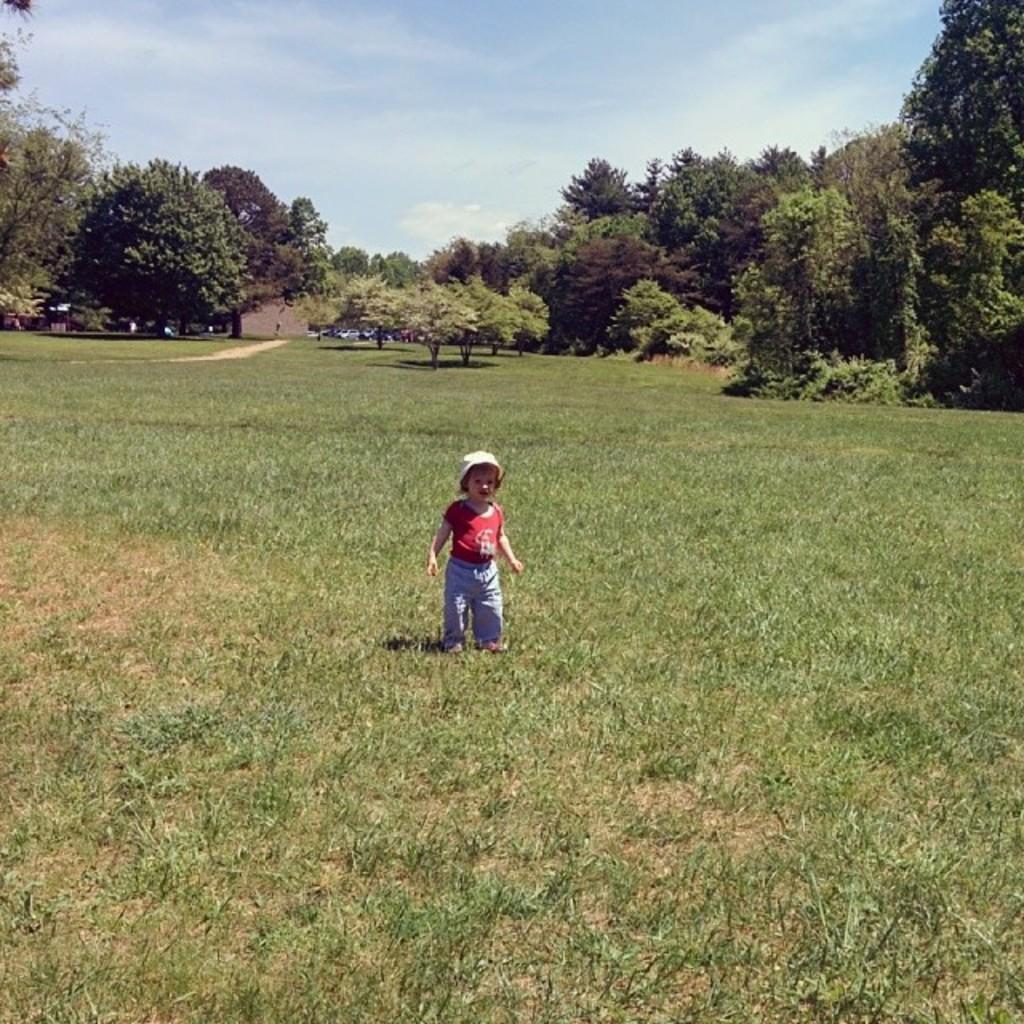Could you give a brief overview of what you see in this image? In this image in the center there is one baby who is standing, and at the bottom there is grass. In the background there are some vehicles and trees, and at the top of the image there is sky. 